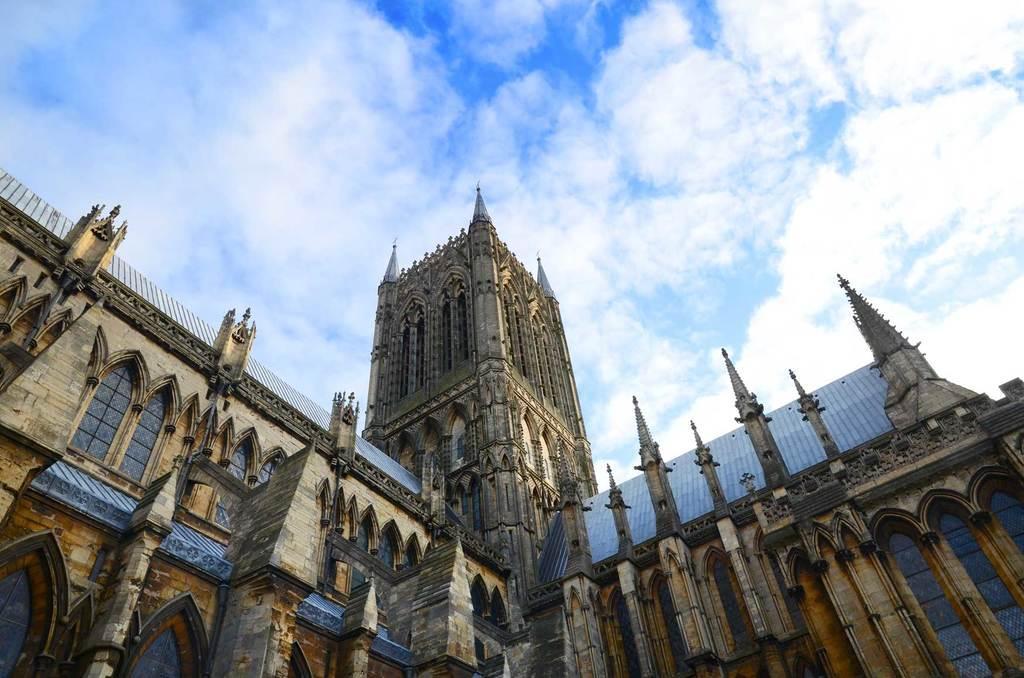Could you give a brief overview of what you see in this image? In this image I can see at the bottom it looks like a building, at the top there is the cloudy sky. 